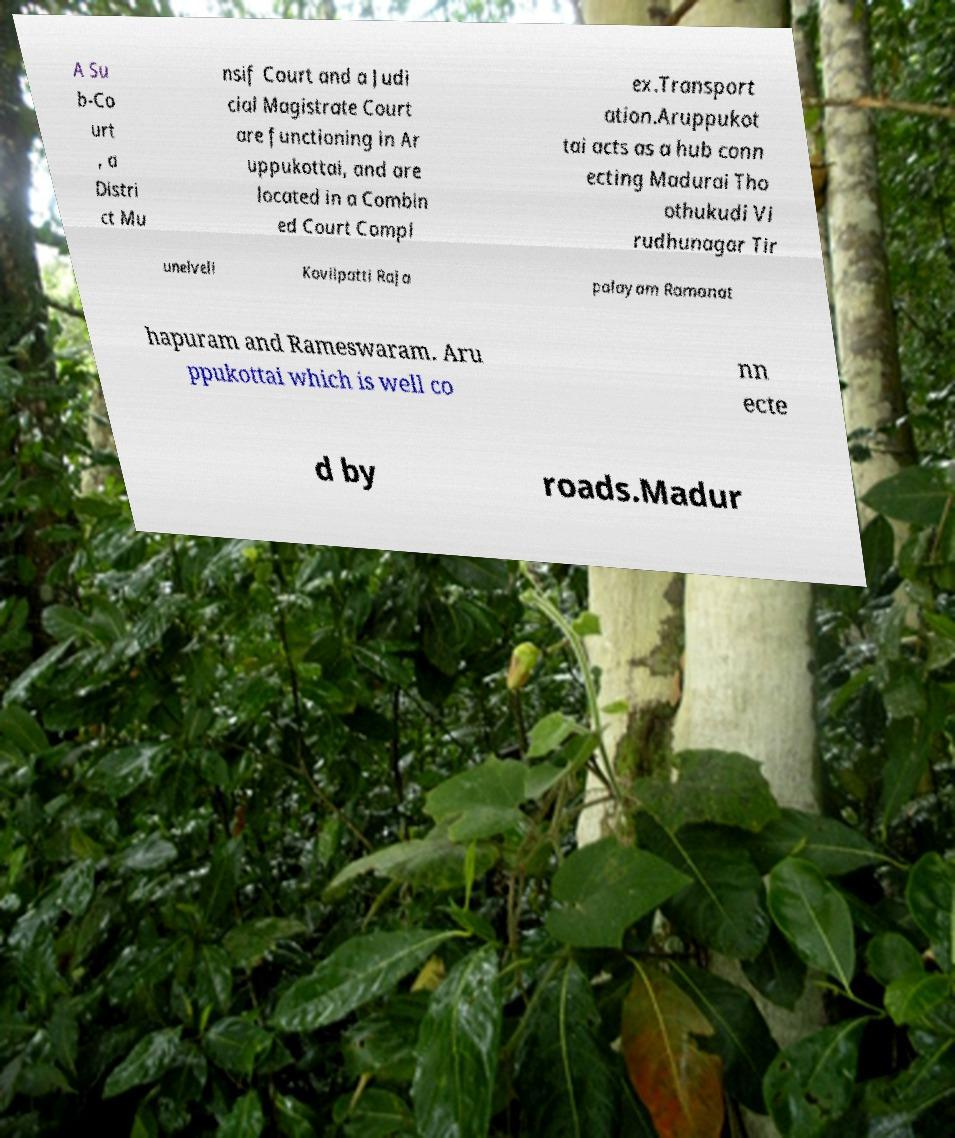Can you read and provide the text displayed in the image?This photo seems to have some interesting text. Can you extract and type it out for me? A Su b-Co urt , a Distri ct Mu nsif Court and a Judi cial Magistrate Court are functioning in Ar uppukottai, and are located in a Combin ed Court Compl ex.Transport ation.Aruppukot tai acts as a hub conn ecting Madurai Tho othukudi Vi rudhunagar Tir unelveli Kovilpatti Raja palayam Ramanat hapuram and Rameswaram. Aru ppukottai which is well co nn ecte d by roads.Madur 